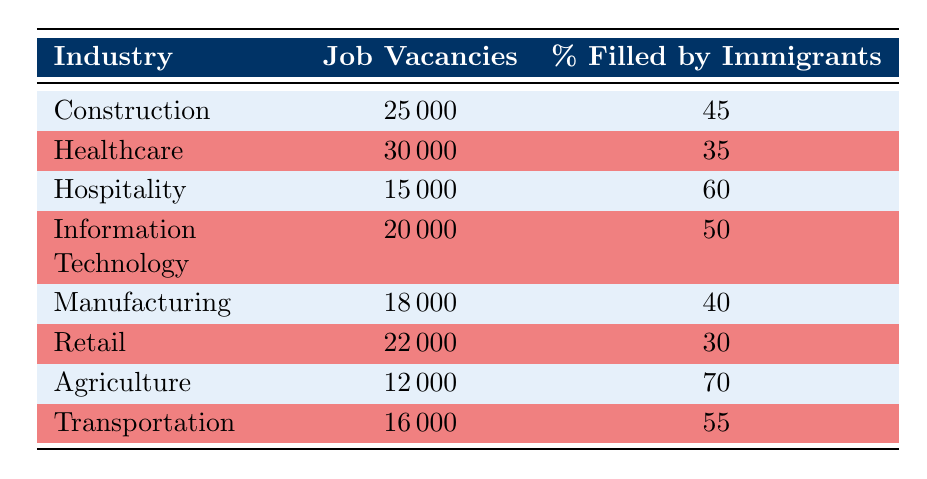What is the total number of job vacancies across all industries listed? To find the total job vacancies, sum the job vacancies of each industry: 25000 (Construction) + 30000 (Healthcare) + 15000 (Hospitality) + 20000 (Information Technology) + 18000 (Manufacturing) + 22000 (Retail) + 12000 (Agriculture) + 16000 (Transportation) = 188000
Answer: 188000 Which industry has the highest percentage of job vacancies filled by immigrant workers? Looking at the percentage filled by immigrant workers in each industry, Agriculture has the highest percentage at 70%.
Answer: Agriculture Is the percentage of job vacancies filled by immigrant workers in Retail higher than in Manufacturing? The percentage for Retail is 30% and for Manufacturing is 40%. Since 30% is not higher than 40%, the answer is no.
Answer: No What is the average percentage of job vacancies filled by immigrant workers across all industries? To find the average, sum the percentages: (45 + 35 + 60 + 50 + 40 + 30 + 70 + 55) = 385. There are 8 industries, so average = 385 / 8 = 48.125.
Answer: 48.125 Are there more job vacancies in Hospitality than in Transportation? Hospitality has 15000 job vacancies and Transportation has 16000. Since 15000 is less than 16000, the answer is no.
Answer: No What is the percentage difference in job vacancies filled by immigrant workers between Agriculture and Healthcare? Agriculture has 70% and Healthcare has 35%. The difference is calculated as 70 - 35 = 35%.
Answer: 35% In which two industries is the percentage of job vacancies filled by immigrant workers equal to or greater than 50%? From the table, Hospitality (60%) and Agriculture (70%) both have percentages that meet the criteria, as they are equal to or greater than 50%.
Answer: Hospitality and Agriculture What is the total percentage of job vacancies filled by immigrant workers for the Construction and Information Technology industries? The percentages for Construction and Information Technology are 45% and 50%, respectively. Their sum is 45 + 50 = 95%.
Answer: 95% 